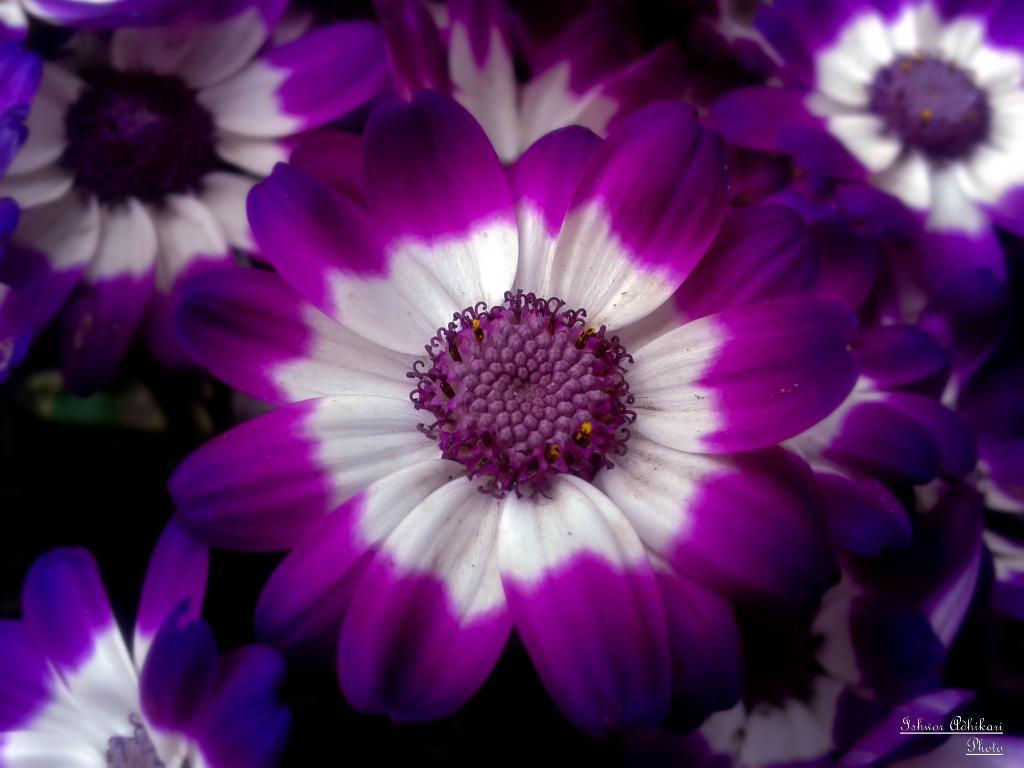What colors are the flowers in the image? The flowers in the image are purple and white. Can you describe the text at the bottom right of the image? There is some text at the right bottom of the image. What type of owl can be seen sitting on the plate in the image? There is no owl or plate present in the image; it only features flowers and text. 